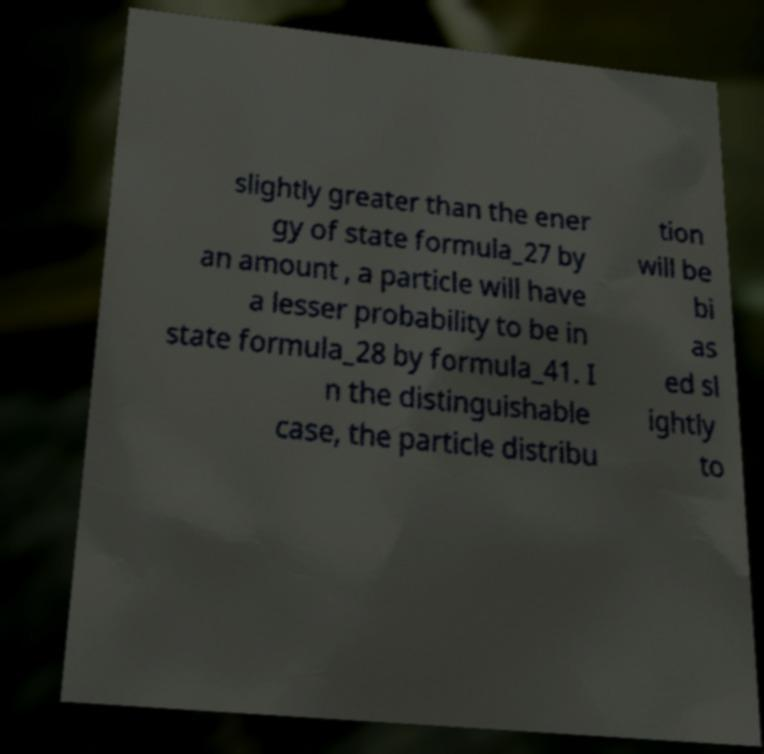What messages or text are displayed in this image? I need them in a readable, typed format. slightly greater than the ener gy of state formula_27 by an amount , a particle will have a lesser probability to be in state formula_28 by formula_41. I n the distinguishable case, the particle distribu tion will be bi as ed sl ightly to 